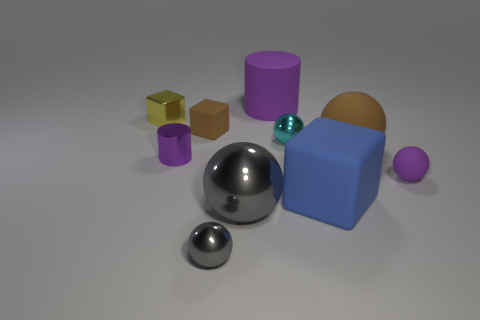Subtract all brown spheres. How many spheres are left? 4 Subtract all tiny matte balls. How many balls are left? 4 Subtract all yellow balls. Subtract all brown cylinders. How many balls are left? 5 Subtract all cubes. How many objects are left? 7 Add 6 small blue matte blocks. How many small blue matte blocks exist? 6 Subtract 1 purple spheres. How many objects are left? 9 Subtract all tiny gray metallic balls. Subtract all purple metallic cubes. How many objects are left? 9 Add 1 large gray metallic objects. How many large gray metallic objects are left? 2 